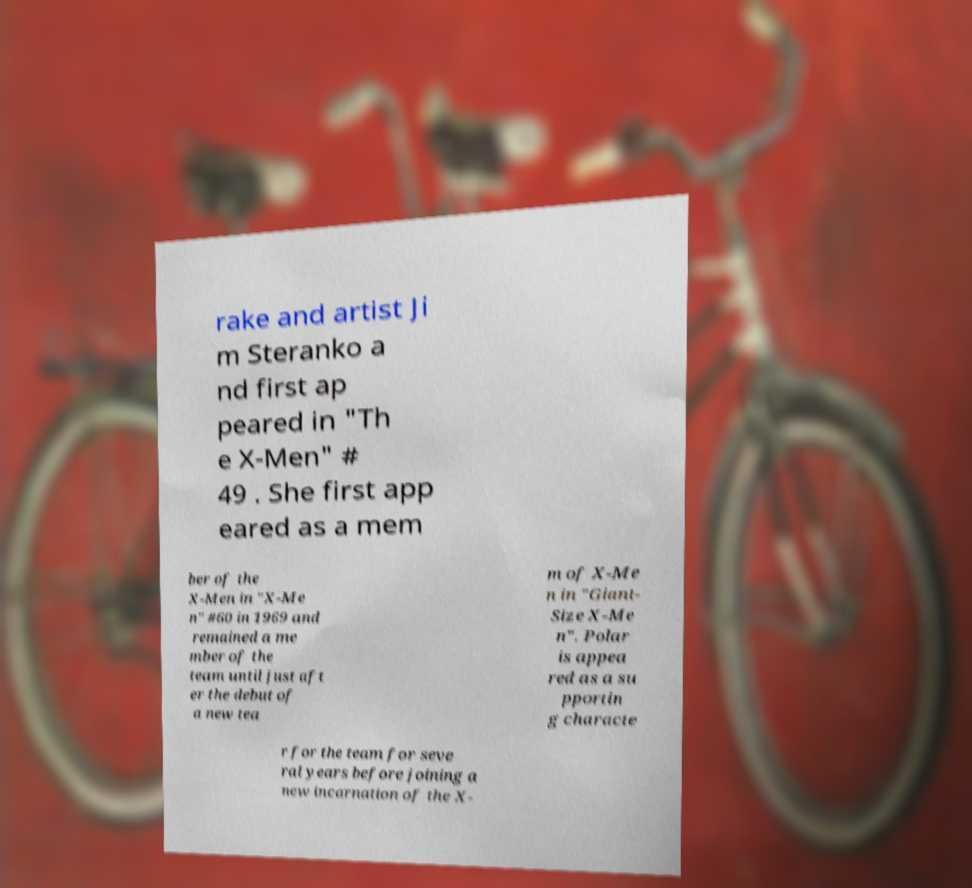For documentation purposes, I need the text within this image transcribed. Could you provide that? rake and artist Ji m Steranko a nd first ap peared in "Th e X-Men" # 49 . She first app eared as a mem ber of the X-Men in "X-Me n" #60 in 1969 and remained a me mber of the team until just aft er the debut of a new tea m of X-Me n in "Giant- Size X-Me n". Polar is appea red as a su pportin g characte r for the team for seve ral years before joining a new incarnation of the X- 